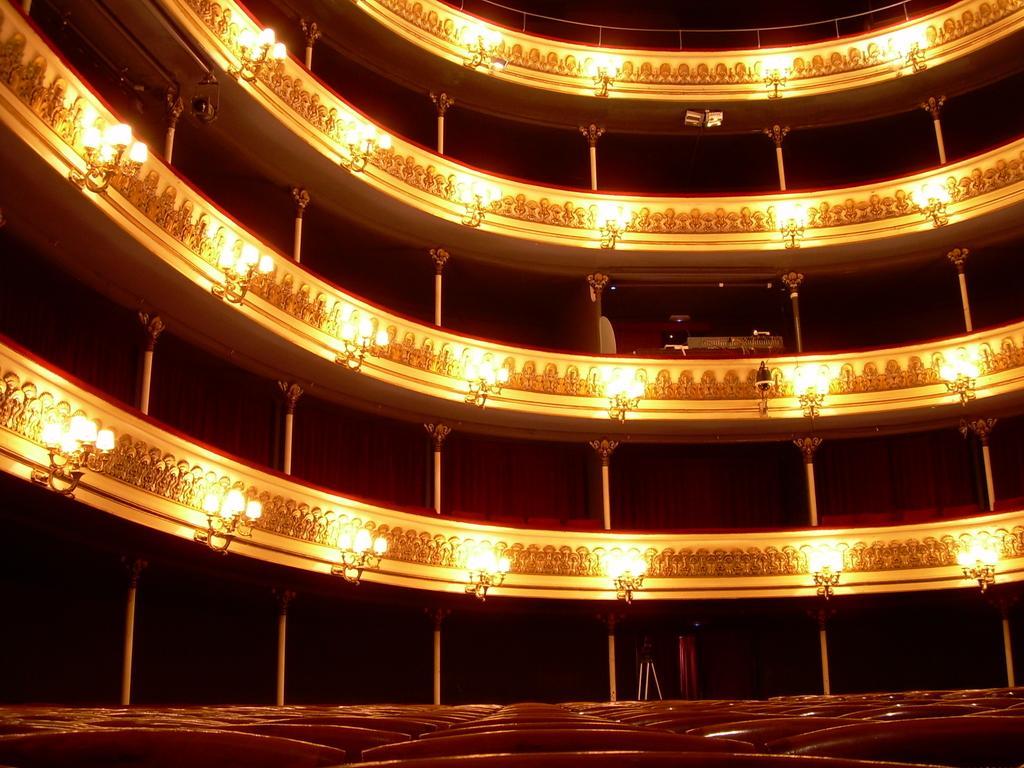Can you describe this image briefly? It is an inside view of a building. Here we can see pillars, railings, curtains, chairs, chandeliers, stand and few objects. 